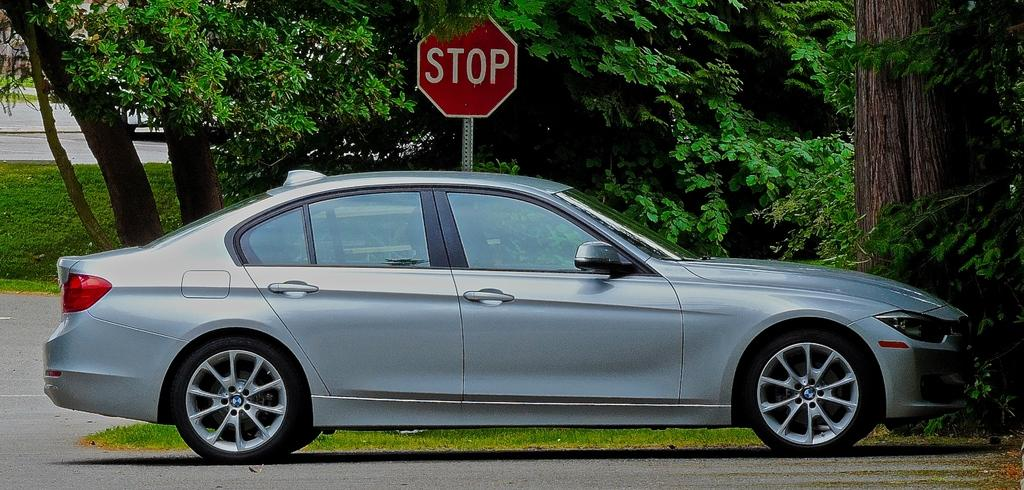What is the main subject in the front of the image? There is a car in the front of the image. What can be seen in the background of the image? There are trees and grass in the background of the image. What type of road sign is present in the background? There is a stop board in the background of the image. What type of bag can be seen hanging from the car's rearview mirror in the image? There is no bag hanging from the car's rearview mirror in the image. 